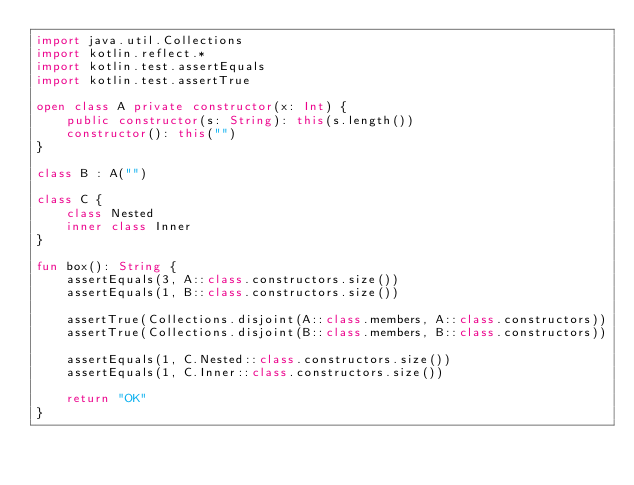Convert code to text. <code><loc_0><loc_0><loc_500><loc_500><_Kotlin_>import java.util.Collections
import kotlin.reflect.*
import kotlin.test.assertEquals
import kotlin.test.assertTrue

open class A private constructor(x: Int) {
    public constructor(s: String): this(s.length())
    constructor(): this("")
}

class B : A("")

class C {
    class Nested
    inner class Inner
}

fun box(): String {
    assertEquals(3, A::class.constructors.size())
    assertEquals(1, B::class.constructors.size())

    assertTrue(Collections.disjoint(A::class.members, A::class.constructors))
    assertTrue(Collections.disjoint(B::class.members, B::class.constructors))

    assertEquals(1, C.Nested::class.constructors.size())
    assertEquals(1, C.Inner::class.constructors.size())

    return "OK"
}
</code> 